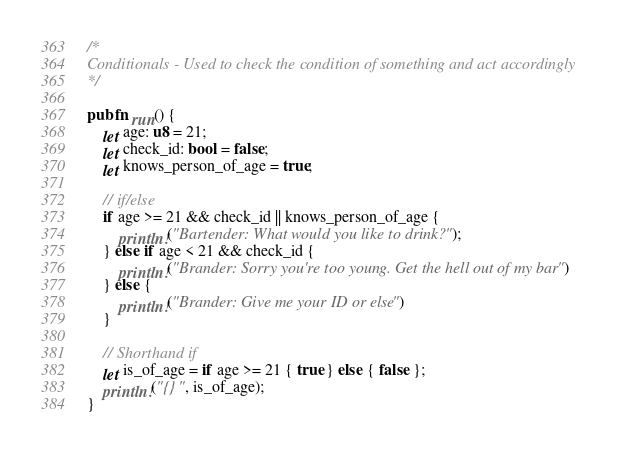<code> <loc_0><loc_0><loc_500><loc_500><_Rust_>/*
Conditionals - Used to check the condition of something and act accordingly
*/

pub fn run() {
    let age: u8 = 21;
    let check_id: bool = false;
    let knows_person_of_age = true;

    // if/else
    if age >= 21 && check_id || knows_person_of_age {
        println!("Bartender: What would you like to drink?");
    } else if age < 21 && check_id {
        println!("Brander: Sorry you're too young. Get the hell out of my bar")
    } else {
        println!("Brander: Give me your ID or else")
    }

    // Shorthand if
    let is_of_age = if age >= 21 { true } else { false };
    println!("{}", is_of_age);
}
</code> 